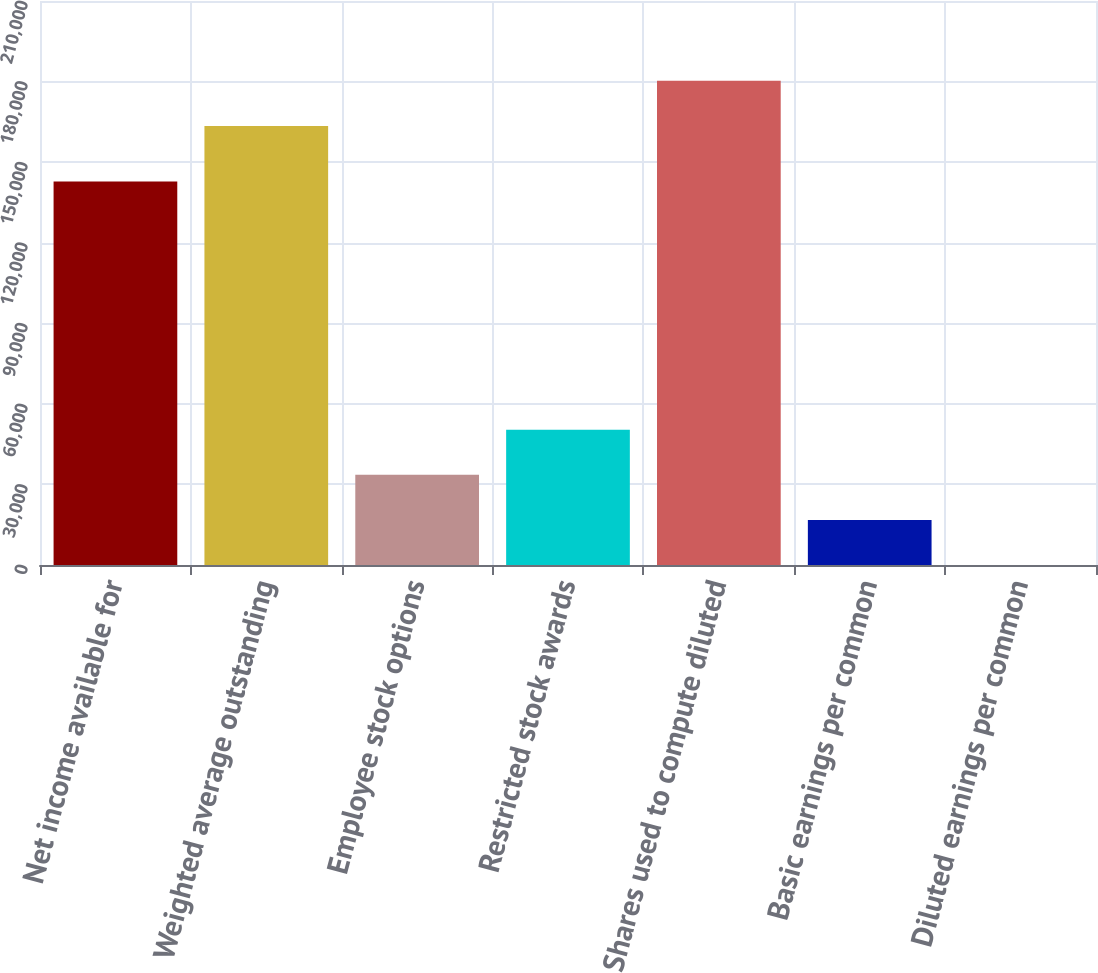Convert chart to OTSL. <chart><loc_0><loc_0><loc_500><loc_500><bar_chart><fcel>Net income available for<fcel>Weighted average outstanding<fcel>Employee stock options<fcel>Restricted stock awards<fcel>Shares used to compute diluted<fcel>Basic earnings per common<fcel>Diluted earnings per common<nl><fcel>142755<fcel>163489<fcel>33560.9<fcel>50340.9<fcel>180269<fcel>16780.9<fcel>0.85<nl></chart> 